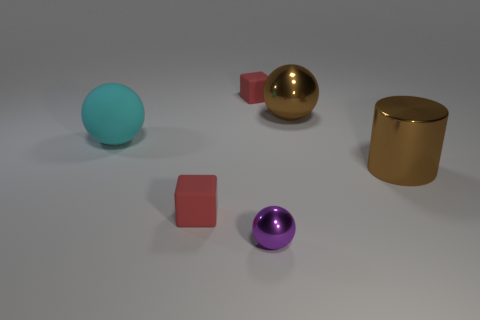There is a tiny matte object that is behind the metal cylinder; does it have the same shape as the small metal object?
Offer a very short reply. No. What number of spheres are either cyan objects or brown shiny objects?
Your answer should be very brief. 2. What number of red rubber blocks are there?
Offer a very short reply. 2. What size is the cyan rubber object in front of the metallic object behind the large cyan matte ball?
Make the answer very short. Large. There is a brown sphere; what number of big brown objects are in front of it?
Make the answer very short. 1. What size is the purple metal object?
Your response must be concise. Small. Is the cube behind the brown ball made of the same material as the large object that is right of the brown ball?
Keep it short and to the point. No. Is there a large metallic sphere of the same color as the large metal cylinder?
Keep it short and to the point. Yes. There is a cylinder that is the same size as the brown ball; what color is it?
Provide a succinct answer. Brown. Do the sphere that is to the left of the small purple thing and the cylinder have the same color?
Keep it short and to the point. No. 